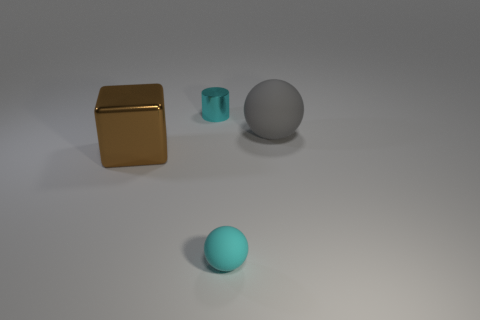Subtract all gray spheres. How many spheres are left? 1 Add 2 matte balls. How many objects exist? 6 Subtract all cubes. How many objects are left? 3 Subtract 1 cylinders. How many cylinders are left? 0 Add 4 gray matte balls. How many gray matte balls are left? 5 Add 3 big rubber things. How many big rubber things exist? 4 Subtract 0 purple cylinders. How many objects are left? 4 Subtract all green balls. Subtract all yellow cubes. How many balls are left? 2 Subtract all big cyan objects. Subtract all large brown blocks. How many objects are left? 3 